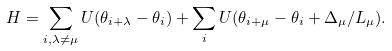Convert formula to latex. <formula><loc_0><loc_0><loc_500><loc_500>H = \sum _ { i , \lambda \neq \mu } U ( \theta _ { i + \lambda } - \theta _ { i } ) + \sum _ { i } U ( \theta _ { i + \mu } - \theta _ { i } + \Delta _ { \mu } / L _ { \mu } ) .</formula> 